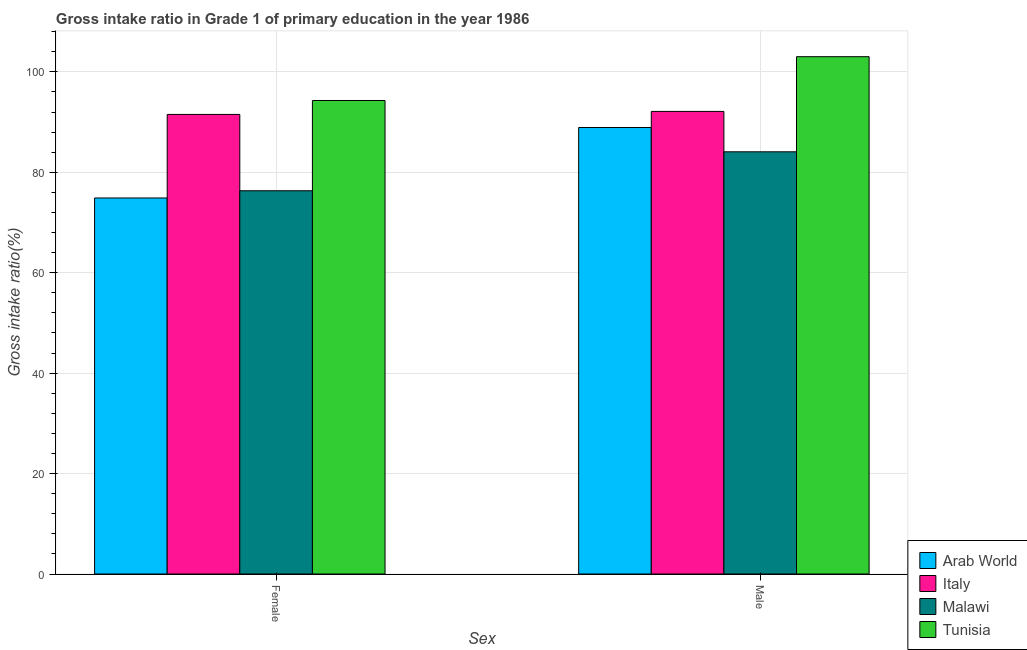How many different coloured bars are there?
Ensure brevity in your answer.  4. How many groups of bars are there?
Ensure brevity in your answer.  2. What is the label of the 2nd group of bars from the left?
Give a very brief answer. Male. What is the gross intake ratio(male) in Tunisia?
Give a very brief answer. 103.03. Across all countries, what is the maximum gross intake ratio(male)?
Offer a terse response. 103.03. Across all countries, what is the minimum gross intake ratio(male)?
Keep it short and to the point. 84.09. In which country was the gross intake ratio(male) maximum?
Make the answer very short. Tunisia. In which country was the gross intake ratio(female) minimum?
Your answer should be compact. Arab World. What is the total gross intake ratio(female) in the graph?
Your answer should be compact. 337.05. What is the difference between the gross intake ratio(female) in Tunisia and that in Arab World?
Provide a short and direct response. 19.41. What is the difference between the gross intake ratio(female) in Malawi and the gross intake ratio(male) in Arab World?
Provide a succinct answer. -12.6. What is the average gross intake ratio(male) per country?
Your answer should be very brief. 92.04. What is the difference between the gross intake ratio(female) and gross intake ratio(male) in Tunisia?
Provide a short and direct response. -8.72. What is the ratio of the gross intake ratio(male) in Arab World to that in Tunisia?
Keep it short and to the point. 0.86. In how many countries, is the gross intake ratio(male) greater than the average gross intake ratio(male) taken over all countries?
Your response must be concise. 2. What does the 2nd bar from the left in Female represents?
Ensure brevity in your answer.  Italy. What does the 3rd bar from the right in Female represents?
Keep it short and to the point. Italy. How many bars are there?
Your response must be concise. 8. Are all the bars in the graph horizontal?
Give a very brief answer. No. Are the values on the major ticks of Y-axis written in scientific E-notation?
Ensure brevity in your answer.  No. Does the graph contain any zero values?
Keep it short and to the point. No. Does the graph contain grids?
Your answer should be very brief. Yes. Where does the legend appear in the graph?
Your answer should be very brief. Bottom right. How are the legend labels stacked?
Your response must be concise. Vertical. What is the title of the graph?
Give a very brief answer. Gross intake ratio in Grade 1 of primary education in the year 1986. What is the label or title of the X-axis?
Your answer should be very brief. Sex. What is the label or title of the Y-axis?
Offer a very short reply. Gross intake ratio(%). What is the Gross intake ratio(%) of Arab World in Female?
Give a very brief answer. 74.89. What is the Gross intake ratio(%) of Italy in Female?
Your answer should be compact. 91.53. What is the Gross intake ratio(%) of Malawi in Female?
Provide a short and direct response. 76.33. What is the Gross intake ratio(%) in Tunisia in Female?
Provide a succinct answer. 94.3. What is the Gross intake ratio(%) of Arab World in Male?
Give a very brief answer. 88.93. What is the Gross intake ratio(%) of Italy in Male?
Your answer should be very brief. 92.13. What is the Gross intake ratio(%) in Malawi in Male?
Ensure brevity in your answer.  84.09. What is the Gross intake ratio(%) in Tunisia in Male?
Offer a very short reply. 103.03. Across all Sex, what is the maximum Gross intake ratio(%) of Arab World?
Keep it short and to the point. 88.93. Across all Sex, what is the maximum Gross intake ratio(%) of Italy?
Your answer should be very brief. 92.13. Across all Sex, what is the maximum Gross intake ratio(%) in Malawi?
Provide a succinct answer. 84.09. Across all Sex, what is the maximum Gross intake ratio(%) of Tunisia?
Provide a short and direct response. 103.03. Across all Sex, what is the minimum Gross intake ratio(%) in Arab World?
Give a very brief answer. 74.89. Across all Sex, what is the minimum Gross intake ratio(%) of Italy?
Ensure brevity in your answer.  91.53. Across all Sex, what is the minimum Gross intake ratio(%) of Malawi?
Make the answer very short. 76.33. Across all Sex, what is the minimum Gross intake ratio(%) in Tunisia?
Keep it short and to the point. 94.3. What is the total Gross intake ratio(%) in Arab World in the graph?
Make the answer very short. 163.82. What is the total Gross intake ratio(%) in Italy in the graph?
Make the answer very short. 183.66. What is the total Gross intake ratio(%) in Malawi in the graph?
Give a very brief answer. 160.41. What is the total Gross intake ratio(%) in Tunisia in the graph?
Offer a very short reply. 197.33. What is the difference between the Gross intake ratio(%) of Arab World in Female and that in Male?
Your answer should be compact. -14.04. What is the difference between the Gross intake ratio(%) of Italy in Female and that in Male?
Keep it short and to the point. -0.6. What is the difference between the Gross intake ratio(%) of Malawi in Female and that in Male?
Your response must be concise. -7.76. What is the difference between the Gross intake ratio(%) of Tunisia in Female and that in Male?
Give a very brief answer. -8.72. What is the difference between the Gross intake ratio(%) in Arab World in Female and the Gross intake ratio(%) in Italy in Male?
Ensure brevity in your answer.  -17.24. What is the difference between the Gross intake ratio(%) of Arab World in Female and the Gross intake ratio(%) of Malawi in Male?
Provide a short and direct response. -9.2. What is the difference between the Gross intake ratio(%) of Arab World in Female and the Gross intake ratio(%) of Tunisia in Male?
Give a very brief answer. -28.14. What is the difference between the Gross intake ratio(%) in Italy in Female and the Gross intake ratio(%) in Malawi in Male?
Your answer should be compact. 7.44. What is the difference between the Gross intake ratio(%) in Italy in Female and the Gross intake ratio(%) in Tunisia in Male?
Offer a terse response. -11.5. What is the difference between the Gross intake ratio(%) in Malawi in Female and the Gross intake ratio(%) in Tunisia in Male?
Ensure brevity in your answer.  -26.7. What is the average Gross intake ratio(%) in Arab World per Sex?
Offer a very short reply. 81.91. What is the average Gross intake ratio(%) in Italy per Sex?
Offer a terse response. 91.83. What is the average Gross intake ratio(%) in Malawi per Sex?
Offer a very short reply. 80.21. What is the average Gross intake ratio(%) of Tunisia per Sex?
Your answer should be very brief. 98.67. What is the difference between the Gross intake ratio(%) of Arab World and Gross intake ratio(%) of Italy in Female?
Ensure brevity in your answer.  -16.64. What is the difference between the Gross intake ratio(%) in Arab World and Gross intake ratio(%) in Malawi in Female?
Make the answer very short. -1.44. What is the difference between the Gross intake ratio(%) of Arab World and Gross intake ratio(%) of Tunisia in Female?
Ensure brevity in your answer.  -19.41. What is the difference between the Gross intake ratio(%) in Italy and Gross intake ratio(%) in Malawi in Female?
Give a very brief answer. 15.2. What is the difference between the Gross intake ratio(%) of Italy and Gross intake ratio(%) of Tunisia in Female?
Your answer should be compact. -2.78. What is the difference between the Gross intake ratio(%) of Malawi and Gross intake ratio(%) of Tunisia in Female?
Your answer should be compact. -17.98. What is the difference between the Gross intake ratio(%) of Arab World and Gross intake ratio(%) of Italy in Male?
Give a very brief answer. -3.2. What is the difference between the Gross intake ratio(%) of Arab World and Gross intake ratio(%) of Malawi in Male?
Keep it short and to the point. 4.84. What is the difference between the Gross intake ratio(%) in Arab World and Gross intake ratio(%) in Tunisia in Male?
Keep it short and to the point. -14.1. What is the difference between the Gross intake ratio(%) of Italy and Gross intake ratio(%) of Malawi in Male?
Your answer should be compact. 8.04. What is the difference between the Gross intake ratio(%) in Italy and Gross intake ratio(%) in Tunisia in Male?
Your response must be concise. -10.9. What is the difference between the Gross intake ratio(%) in Malawi and Gross intake ratio(%) in Tunisia in Male?
Provide a short and direct response. -18.94. What is the ratio of the Gross intake ratio(%) in Arab World in Female to that in Male?
Give a very brief answer. 0.84. What is the ratio of the Gross intake ratio(%) of Malawi in Female to that in Male?
Your response must be concise. 0.91. What is the ratio of the Gross intake ratio(%) in Tunisia in Female to that in Male?
Give a very brief answer. 0.92. What is the difference between the highest and the second highest Gross intake ratio(%) of Arab World?
Give a very brief answer. 14.04. What is the difference between the highest and the second highest Gross intake ratio(%) in Italy?
Your answer should be very brief. 0.6. What is the difference between the highest and the second highest Gross intake ratio(%) in Malawi?
Offer a very short reply. 7.76. What is the difference between the highest and the second highest Gross intake ratio(%) of Tunisia?
Offer a very short reply. 8.72. What is the difference between the highest and the lowest Gross intake ratio(%) in Arab World?
Keep it short and to the point. 14.04. What is the difference between the highest and the lowest Gross intake ratio(%) of Italy?
Your answer should be compact. 0.6. What is the difference between the highest and the lowest Gross intake ratio(%) in Malawi?
Provide a succinct answer. 7.76. What is the difference between the highest and the lowest Gross intake ratio(%) in Tunisia?
Provide a succinct answer. 8.72. 